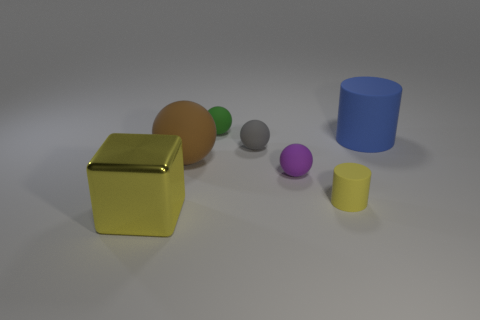What number of other objects are there of the same size as the purple rubber sphere?
Offer a terse response. 3. The small matte cylinder is what color?
Your answer should be very brief. Yellow. There is a large thing to the right of the yellow rubber cylinder; what is its material?
Keep it short and to the point. Rubber. Is the number of small purple rubber objects to the left of the small green rubber ball the same as the number of big rubber balls?
Your answer should be compact. No. Is the gray object the same shape as the big blue matte object?
Ensure brevity in your answer.  No. Are there any other things of the same color as the large rubber cylinder?
Offer a terse response. No. What shape is the small object that is behind the large brown rubber thing and in front of the blue cylinder?
Provide a short and direct response. Sphere. Is the number of purple spheres that are behind the big ball the same as the number of brown matte objects that are on the right side of the green rubber sphere?
Provide a short and direct response. Yes. What number of spheres are yellow shiny objects or large objects?
Provide a succinct answer. 1. How many small green blocks are made of the same material as the brown thing?
Offer a terse response. 0. 